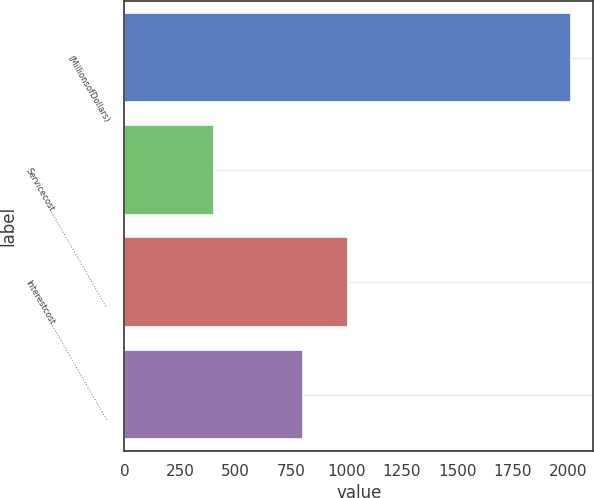Convert chart. <chart><loc_0><loc_0><loc_500><loc_500><bar_chart><fcel>(MillionsofDollars)<fcel>Servicecost…………………………………<fcel>Interestcost…………………………………<fcel>Unnamed: 3<nl><fcel>2012<fcel>403.2<fcel>1006.5<fcel>805.4<nl></chart> 